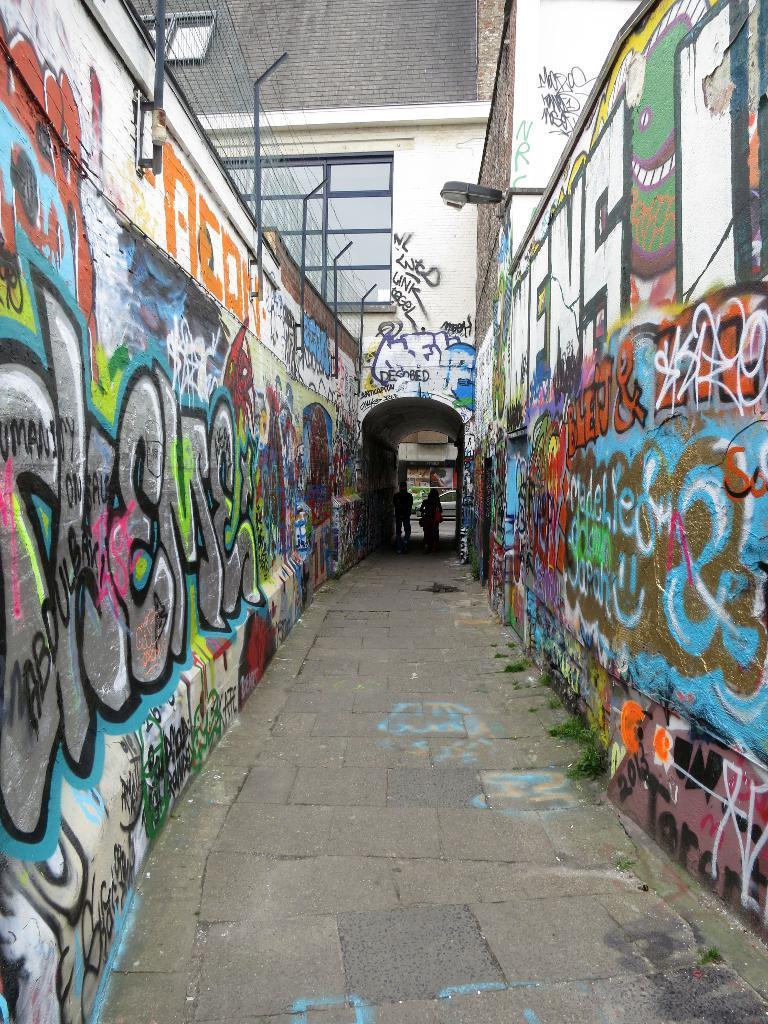Describe this image in one or two sentences. In the center of the image we can see some people standing on a pathway. We can also see the walls with graffiti. On the backside we can see a fence, a street pole and a building with windows. 